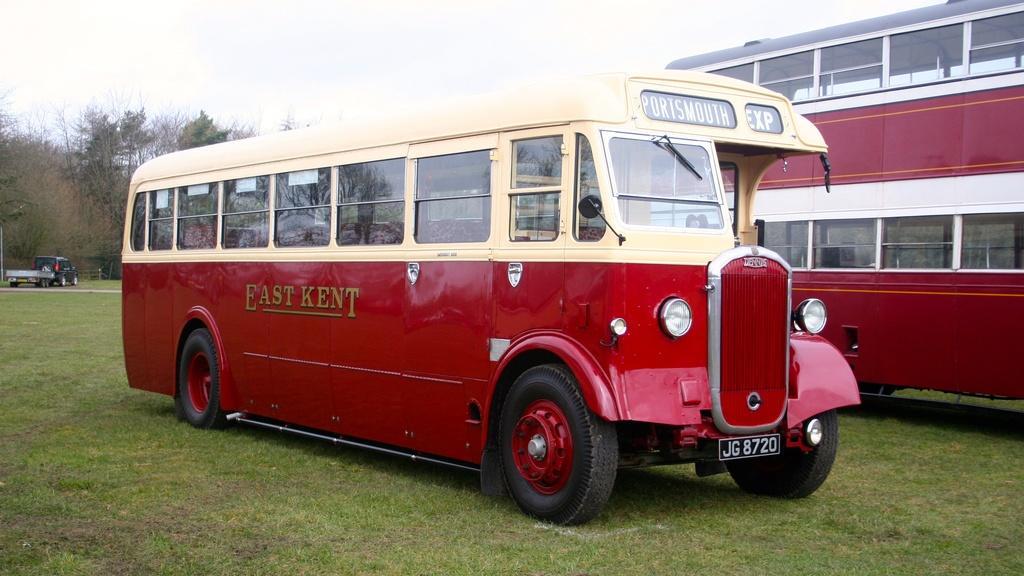Please provide a concise description of this image. In this image there is a red color bus, Double Decker bus and a truck on the grass, and in the background there are trees,sky. 